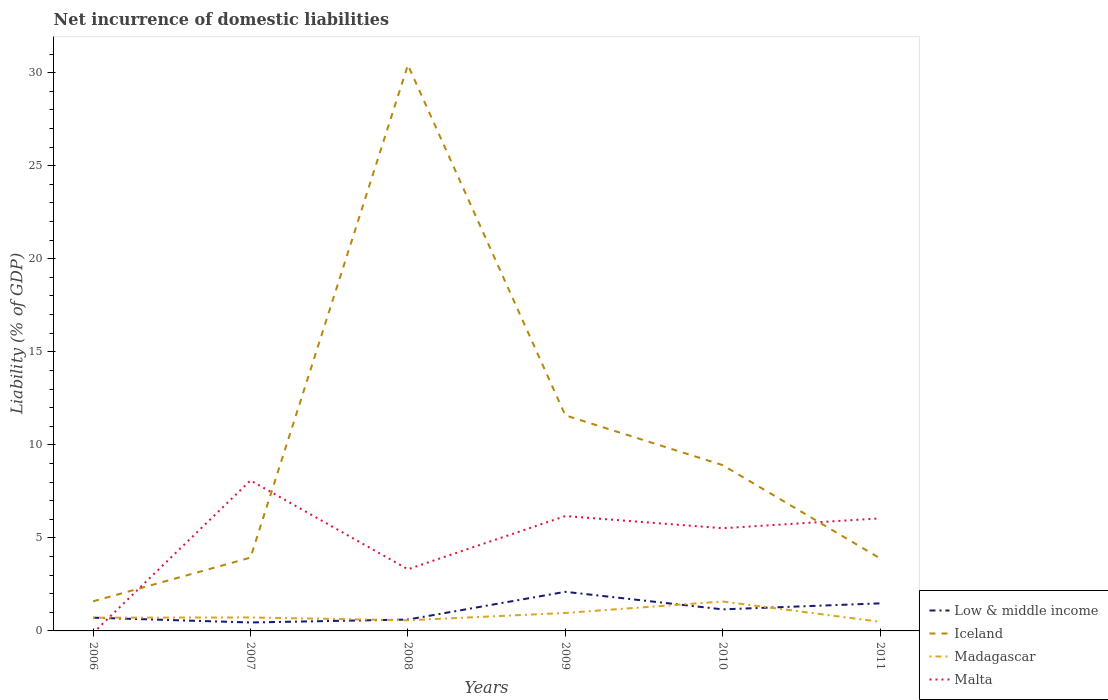Does the line corresponding to Madagascar intersect with the line corresponding to Iceland?
Ensure brevity in your answer.  No. Across all years, what is the maximum net incurrence of domestic liabilities in Malta?
Your response must be concise. 0. What is the total net incurrence of domestic liabilities in Iceland in the graph?
Your response must be concise. -10. What is the difference between the highest and the second highest net incurrence of domestic liabilities in Low & middle income?
Offer a terse response. 1.65. Is the net incurrence of domestic liabilities in Madagascar strictly greater than the net incurrence of domestic liabilities in Malta over the years?
Your response must be concise. No. How many lines are there?
Offer a very short reply. 4. How many years are there in the graph?
Make the answer very short. 6. Does the graph contain any zero values?
Your response must be concise. Yes. Where does the legend appear in the graph?
Ensure brevity in your answer.  Bottom right. How are the legend labels stacked?
Give a very brief answer. Vertical. What is the title of the graph?
Provide a short and direct response. Net incurrence of domestic liabilities. What is the label or title of the X-axis?
Your answer should be very brief. Years. What is the label or title of the Y-axis?
Your answer should be compact. Liability (% of GDP). What is the Liability (% of GDP) in Low & middle income in 2006?
Provide a short and direct response. 0.71. What is the Liability (% of GDP) of Iceland in 2006?
Your response must be concise. 1.59. What is the Liability (% of GDP) in Madagascar in 2006?
Provide a succinct answer. 0.71. What is the Liability (% of GDP) of Low & middle income in 2007?
Your answer should be very brief. 0.45. What is the Liability (% of GDP) of Iceland in 2007?
Make the answer very short. 3.94. What is the Liability (% of GDP) in Madagascar in 2007?
Make the answer very short. 0.72. What is the Liability (% of GDP) in Malta in 2007?
Offer a very short reply. 8.09. What is the Liability (% of GDP) of Low & middle income in 2008?
Give a very brief answer. 0.61. What is the Liability (% of GDP) in Iceland in 2008?
Your answer should be compact. 30.41. What is the Liability (% of GDP) in Madagascar in 2008?
Your answer should be very brief. 0.57. What is the Liability (% of GDP) in Malta in 2008?
Provide a short and direct response. 3.31. What is the Liability (% of GDP) in Low & middle income in 2009?
Your answer should be compact. 2.1. What is the Liability (% of GDP) in Iceland in 2009?
Offer a very short reply. 11.59. What is the Liability (% of GDP) of Madagascar in 2009?
Provide a succinct answer. 0.97. What is the Liability (% of GDP) in Malta in 2009?
Give a very brief answer. 6.17. What is the Liability (% of GDP) of Low & middle income in 2010?
Give a very brief answer. 1.16. What is the Liability (% of GDP) in Iceland in 2010?
Your answer should be compact. 8.91. What is the Liability (% of GDP) in Madagascar in 2010?
Your response must be concise. 1.58. What is the Liability (% of GDP) of Malta in 2010?
Offer a very short reply. 5.52. What is the Liability (% of GDP) of Low & middle income in 2011?
Provide a succinct answer. 1.48. What is the Liability (% of GDP) in Iceland in 2011?
Your response must be concise. 3.9. What is the Liability (% of GDP) of Madagascar in 2011?
Your answer should be compact. 0.49. What is the Liability (% of GDP) of Malta in 2011?
Provide a short and direct response. 6.05. Across all years, what is the maximum Liability (% of GDP) of Low & middle income?
Offer a terse response. 2.1. Across all years, what is the maximum Liability (% of GDP) in Iceland?
Ensure brevity in your answer.  30.41. Across all years, what is the maximum Liability (% of GDP) of Madagascar?
Give a very brief answer. 1.58. Across all years, what is the maximum Liability (% of GDP) of Malta?
Provide a succinct answer. 8.09. Across all years, what is the minimum Liability (% of GDP) in Low & middle income?
Provide a succinct answer. 0.45. Across all years, what is the minimum Liability (% of GDP) of Iceland?
Your response must be concise. 1.59. Across all years, what is the minimum Liability (% of GDP) of Madagascar?
Offer a terse response. 0.49. What is the total Liability (% of GDP) of Low & middle income in the graph?
Offer a very short reply. 6.52. What is the total Liability (% of GDP) in Iceland in the graph?
Give a very brief answer. 60.34. What is the total Liability (% of GDP) in Madagascar in the graph?
Offer a very short reply. 5.04. What is the total Liability (% of GDP) in Malta in the graph?
Provide a succinct answer. 29.14. What is the difference between the Liability (% of GDP) in Low & middle income in 2006 and that in 2007?
Provide a short and direct response. 0.26. What is the difference between the Liability (% of GDP) of Iceland in 2006 and that in 2007?
Keep it short and to the point. -2.35. What is the difference between the Liability (% of GDP) in Madagascar in 2006 and that in 2007?
Provide a short and direct response. -0.01. What is the difference between the Liability (% of GDP) in Low & middle income in 2006 and that in 2008?
Give a very brief answer. 0.1. What is the difference between the Liability (% of GDP) of Iceland in 2006 and that in 2008?
Make the answer very short. -28.82. What is the difference between the Liability (% of GDP) in Madagascar in 2006 and that in 2008?
Provide a succinct answer. 0.14. What is the difference between the Liability (% of GDP) in Low & middle income in 2006 and that in 2009?
Provide a succinct answer. -1.39. What is the difference between the Liability (% of GDP) of Iceland in 2006 and that in 2009?
Your answer should be compact. -10. What is the difference between the Liability (% of GDP) of Madagascar in 2006 and that in 2009?
Provide a succinct answer. -0.25. What is the difference between the Liability (% of GDP) in Low & middle income in 2006 and that in 2010?
Provide a succinct answer. -0.45. What is the difference between the Liability (% of GDP) in Iceland in 2006 and that in 2010?
Give a very brief answer. -7.32. What is the difference between the Liability (% of GDP) of Madagascar in 2006 and that in 2010?
Give a very brief answer. -0.87. What is the difference between the Liability (% of GDP) of Low & middle income in 2006 and that in 2011?
Your answer should be compact. -0.77. What is the difference between the Liability (% of GDP) of Iceland in 2006 and that in 2011?
Make the answer very short. -2.31. What is the difference between the Liability (% of GDP) in Madagascar in 2006 and that in 2011?
Give a very brief answer. 0.22. What is the difference between the Liability (% of GDP) in Low & middle income in 2007 and that in 2008?
Your response must be concise. -0.16. What is the difference between the Liability (% of GDP) of Iceland in 2007 and that in 2008?
Your answer should be very brief. -26.48. What is the difference between the Liability (% of GDP) of Madagascar in 2007 and that in 2008?
Ensure brevity in your answer.  0.15. What is the difference between the Liability (% of GDP) in Malta in 2007 and that in 2008?
Make the answer very short. 4.78. What is the difference between the Liability (% of GDP) in Low & middle income in 2007 and that in 2009?
Offer a very short reply. -1.65. What is the difference between the Liability (% of GDP) in Iceland in 2007 and that in 2009?
Your response must be concise. -7.65. What is the difference between the Liability (% of GDP) in Madagascar in 2007 and that in 2009?
Ensure brevity in your answer.  -0.24. What is the difference between the Liability (% of GDP) of Malta in 2007 and that in 2009?
Make the answer very short. 1.92. What is the difference between the Liability (% of GDP) in Low & middle income in 2007 and that in 2010?
Offer a very short reply. -0.7. What is the difference between the Liability (% of GDP) in Iceland in 2007 and that in 2010?
Your response must be concise. -4.97. What is the difference between the Liability (% of GDP) of Madagascar in 2007 and that in 2010?
Your response must be concise. -0.86. What is the difference between the Liability (% of GDP) in Malta in 2007 and that in 2010?
Offer a very short reply. 2.57. What is the difference between the Liability (% of GDP) of Low & middle income in 2007 and that in 2011?
Provide a short and direct response. -1.03. What is the difference between the Liability (% of GDP) in Iceland in 2007 and that in 2011?
Ensure brevity in your answer.  0.04. What is the difference between the Liability (% of GDP) in Madagascar in 2007 and that in 2011?
Make the answer very short. 0.23. What is the difference between the Liability (% of GDP) of Malta in 2007 and that in 2011?
Give a very brief answer. 2.04. What is the difference between the Liability (% of GDP) of Low & middle income in 2008 and that in 2009?
Keep it short and to the point. -1.49. What is the difference between the Liability (% of GDP) in Iceland in 2008 and that in 2009?
Provide a succinct answer. 18.83. What is the difference between the Liability (% of GDP) of Madagascar in 2008 and that in 2009?
Your answer should be compact. -0.39. What is the difference between the Liability (% of GDP) in Malta in 2008 and that in 2009?
Your response must be concise. -2.86. What is the difference between the Liability (% of GDP) in Low & middle income in 2008 and that in 2010?
Ensure brevity in your answer.  -0.55. What is the difference between the Liability (% of GDP) of Iceland in 2008 and that in 2010?
Give a very brief answer. 21.51. What is the difference between the Liability (% of GDP) of Madagascar in 2008 and that in 2010?
Ensure brevity in your answer.  -1.01. What is the difference between the Liability (% of GDP) in Malta in 2008 and that in 2010?
Keep it short and to the point. -2.21. What is the difference between the Liability (% of GDP) in Low & middle income in 2008 and that in 2011?
Offer a terse response. -0.87. What is the difference between the Liability (% of GDP) of Iceland in 2008 and that in 2011?
Offer a very short reply. 26.52. What is the difference between the Liability (% of GDP) in Madagascar in 2008 and that in 2011?
Your answer should be very brief. 0.08. What is the difference between the Liability (% of GDP) in Malta in 2008 and that in 2011?
Offer a terse response. -2.74. What is the difference between the Liability (% of GDP) of Low & middle income in 2009 and that in 2010?
Provide a succinct answer. 0.94. What is the difference between the Liability (% of GDP) of Iceland in 2009 and that in 2010?
Ensure brevity in your answer.  2.68. What is the difference between the Liability (% of GDP) of Madagascar in 2009 and that in 2010?
Offer a terse response. -0.62. What is the difference between the Liability (% of GDP) of Malta in 2009 and that in 2010?
Offer a very short reply. 0.65. What is the difference between the Liability (% of GDP) of Low & middle income in 2009 and that in 2011?
Give a very brief answer. 0.62. What is the difference between the Liability (% of GDP) in Iceland in 2009 and that in 2011?
Offer a terse response. 7.69. What is the difference between the Liability (% of GDP) of Madagascar in 2009 and that in 2011?
Your answer should be very brief. 0.47. What is the difference between the Liability (% of GDP) in Malta in 2009 and that in 2011?
Make the answer very short. 0.12. What is the difference between the Liability (% of GDP) of Low & middle income in 2010 and that in 2011?
Your response must be concise. -0.32. What is the difference between the Liability (% of GDP) in Iceland in 2010 and that in 2011?
Provide a short and direct response. 5.01. What is the difference between the Liability (% of GDP) of Madagascar in 2010 and that in 2011?
Keep it short and to the point. 1.09. What is the difference between the Liability (% of GDP) in Malta in 2010 and that in 2011?
Your answer should be compact. -0.53. What is the difference between the Liability (% of GDP) in Low & middle income in 2006 and the Liability (% of GDP) in Iceland in 2007?
Ensure brevity in your answer.  -3.23. What is the difference between the Liability (% of GDP) of Low & middle income in 2006 and the Liability (% of GDP) of Madagascar in 2007?
Offer a terse response. -0.01. What is the difference between the Liability (% of GDP) in Low & middle income in 2006 and the Liability (% of GDP) in Malta in 2007?
Offer a terse response. -7.38. What is the difference between the Liability (% of GDP) of Iceland in 2006 and the Liability (% of GDP) of Madagascar in 2007?
Your answer should be compact. 0.87. What is the difference between the Liability (% of GDP) of Iceland in 2006 and the Liability (% of GDP) of Malta in 2007?
Provide a short and direct response. -6.5. What is the difference between the Liability (% of GDP) in Madagascar in 2006 and the Liability (% of GDP) in Malta in 2007?
Keep it short and to the point. -7.38. What is the difference between the Liability (% of GDP) of Low & middle income in 2006 and the Liability (% of GDP) of Iceland in 2008?
Give a very brief answer. -29.7. What is the difference between the Liability (% of GDP) of Low & middle income in 2006 and the Liability (% of GDP) of Madagascar in 2008?
Offer a terse response. 0.14. What is the difference between the Liability (% of GDP) in Low & middle income in 2006 and the Liability (% of GDP) in Malta in 2008?
Ensure brevity in your answer.  -2.6. What is the difference between the Liability (% of GDP) in Iceland in 2006 and the Liability (% of GDP) in Madagascar in 2008?
Your answer should be very brief. 1.02. What is the difference between the Liability (% of GDP) in Iceland in 2006 and the Liability (% of GDP) in Malta in 2008?
Ensure brevity in your answer.  -1.72. What is the difference between the Liability (% of GDP) in Madagascar in 2006 and the Liability (% of GDP) in Malta in 2008?
Make the answer very short. -2.6. What is the difference between the Liability (% of GDP) in Low & middle income in 2006 and the Liability (% of GDP) in Iceland in 2009?
Your answer should be compact. -10.88. What is the difference between the Liability (% of GDP) in Low & middle income in 2006 and the Liability (% of GDP) in Madagascar in 2009?
Give a very brief answer. -0.25. What is the difference between the Liability (% of GDP) of Low & middle income in 2006 and the Liability (% of GDP) of Malta in 2009?
Make the answer very short. -5.46. What is the difference between the Liability (% of GDP) in Iceland in 2006 and the Liability (% of GDP) in Madagascar in 2009?
Your answer should be compact. 0.63. What is the difference between the Liability (% of GDP) of Iceland in 2006 and the Liability (% of GDP) of Malta in 2009?
Offer a very short reply. -4.58. What is the difference between the Liability (% of GDP) of Madagascar in 2006 and the Liability (% of GDP) of Malta in 2009?
Provide a succinct answer. -5.46. What is the difference between the Liability (% of GDP) of Low & middle income in 2006 and the Liability (% of GDP) of Iceland in 2010?
Offer a very short reply. -8.2. What is the difference between the Liability (% of GDP) in Low & middle income in 2006 and the Liability (% of GDP) in Madagascar in 2010?
Your response must be concise. -0.87. What is the difference between the Liability (% of GDP) in Low & middle income in 2006 and the Liability (% of GDP) in Malta in 2010?
Keep it short and to the point. -4.81. What is the difference between the Liability (% of GDP) of Iceland in 2006 and the Liability (% of GDP) of Madagascar in 2010?
Your answer should be very brief. 0.01. What is the difference between the Liability (% of GDP) of Iceland in 2006 and the Liability (% of GDP) of Malta in 2010?
Your answer should be compact. -3.93. What is the difference between the Liability (% of GDP) of Madagascar in 2006 and the Liability (% of GDP) of Malta in 2010?
Ensure brevity in your answer.  -4.81. What is the difference between the Liability (% of GDP) of Low & middle income in 2006 and the Liability (% of GDP) of Iceland in 2011?
Give a very brief answer. -3.19. What is the difference between the Liability (% of GDP) in Low & middle income in 2006 and the Liability (% of GDP) in Madagascar in 2011?
Your answer should be compact. 0.22. What is the difference between the Liability (% of GDP) in Low & middle income in 2006 and the Liability (% of GDP) in Malta in 2011?
Keep it short and to the point. -5.34. What is the difference between the Liability (% of GDP) in Iceland in 2006 and the Liability (% of GDP) in Madagascar in 2011?
Your answer should be compact. 1.1. What is the difference between the Liability (% of GDP) in Iceland in 2006 and the Liability (% of GDP) in Malta in 2011?
Your answer should be compact. -4.46. What is the difference between the Liability (% of GDP) in Madagascar in 2006 and the Liability (% of GDP) in Malta in 2011?
Ensure brevity in your answer.  -5.34. What is the difference between the Liability (% of GDP) of Low & middle income in 2007 and the Liability (% of GDP) of Iceland in 2008?
Offer a very short reply. -29.96. What is the difference between the Liability (% of GDP) in Low & middle income in 2007 and the Liability (% of GDP) in Madagascar in 2008?
Offer a terse response. -0.12. What is the difference between the Liability (% of GDP) in Low & middle income in 2007 and the Liability (% of GDP) in Malta in 2008?
Offer a very short reply. -2.86. What is the difference between the Liability (% of GDP) in Iceland in 2007 and the Liability (% of GDP) in Madagascar in 2008?
Your answer should be compact. 3.37. What is the difference between the Liability (% of GDP) of Iceland in 2007 and the Liability (% of GDP) of Malta in 2008?
Give a very brief answer. 0.63. What is the difference between the Liability (% of GDP) of Madagascar in 2007 and the Liability (% of GDP) of Malta in 2008?
Ensure brevity in your answer.  -2.59. What is the difference between the Liability (% of GDP) of Low & middle income in 2007 and the Liability (% of GDP) of Iceland in 2009?
Your response must be concise. -11.13. What is the difference between the Liability (% of GDP) in Low & middle income in 2007 and the Liability (% of GDP) in Madagascar in 2009?
Offer a very short reply. -0.51. What is the difference between the Liability (% of GDP) of Low & middle income in 2007 and the Liability (% of GDP) of Malta in 2009?
Provide a succinct answer. -5.72. What is the difference between the Liability (% of GDP) of Iceland in 2007 and the Liability (% of GDP) of Madagascar in 2009?
Your response must be concise. 2.97. What is the difference between the Liability (% of GDP) of Iceland in 2007 and the Liability (% of GDP) of Malta in 2009?
Your answer should be very brief. -2.23. What is the difference between the Liability (% of GDP) in Madagascar in 2007 and the Liability (% of GDP) in Malta in 2009?
Your answer should be compact. -5.45. What is the difference between the Liability (% of GDP) in Low & middle income in 2007 and the Liability (% of GDP) in Iceland in 2010?
Provide a succinct answer. -8.45. What is the difference between the Liability (% of GDP) in Low & middle income in 2007 and the Liability (% of GDP) in Madagascar in 2010?
Ensure brevity in your answer.  -1.13. What is the difference between the Liability (% of GDP) in Low & middle income in 2007 and the Liability (% of GDP) in Malta in 2010?
Your answer should be very brief. -5.07. What is the difference between the Liability (% of GDP) in Iceland in 2007 and the Liability (% of GDP) in Madagascar in 2010?
Provide a short and direct response. 2.36. What is the difference between the Liability (% of GDP) of Iceland in 2007 and the Liability (% of GDP) of Malta in 2010?
Make the answer very short. -1.58. What is the difference between the Liability (% of GDP) of Madagascar in 2007 and the Liability (% of GDP) of Malta in 2010?
Your answer should be very brief. -4.8. What is the difference between the Liability (% of GDP) in Low & middle income in 2007 and the Liability (% of GDP) in Iceland in 2011?
Offer a terse response. -3.44. What is the difference between the Liability (% of GDP) of Low & middle income in 2007 and the Liability (% of GDP) of Madagascar in 2011?
Your answer should be very brief. -0.04. What is the difference between the Liability (% of GDP) in Low & middle income in 2007 and the Liability (% of GDP) in Malta in 2011?
Ensure brevity in your answer.  -5.6. What is the difference between the Liability (% of GDP) in Iceland in 2007 and the Liability (% of GDP) in Madagascar in 2011?
Your answer should be very brief. 3.45. What is the difference between the Liability (% of GDP) of Iceland in 2007 and the Liability (% of GDP) of Malta in 2011?
Keep it short and to the point. -2.11. What is the difference between the Liability (% of GDP) in Madagascar in 2007 and the Liability (% of GDP) in Malta in 2011?
Give a very brief answer. -5.33. What is the difference between the Liability (% of GDP) of Low & middle income in 2008 and the Liability (% of GDP) of Iceland in 2009?
Provide a succinct answer. -10.97. What is the difference between the Liability (% of GDP) of Low & middle income in 2008 and the Liability (% of GDP) of Madagascar in 2009?
Offer a very short reply. -0.35. What is the difference between the Liability (% of GDP) in Low & middle income in 2008 and the Liability (% of GDP) in Malta in 2009?
Offer a terse response. -5.56. What is the difference between the Liability (% of GDP) of Iceland in 2008 and the Liability (% of GDP) of Madagascar in 2009?
Offer a terse response. 29.45. What is the difference between the Liability (% of GDP) in Iceland in 2008 and the Liability (% of GDP) in Malta in 2009?
Your response must be concise. 24.24. What is the difference between the Liability (% of GDP) in Madagascar in 2008 and the Liability (% of GDP) in Malta in 2009?
Your response must be concise. -5.6. What is the difference between the Liability (% of GDP) of Low & middle income in 2008 and the Liability (% of GDP) of Iceland in 2010?
Your answer should be very brief. -8.3. What is the difference between the Liability (% of GDP) in Low & middle income in 2008 and the Liability (% of GDP) in Madagascar in 2010?
Your answer should be very brief. -0.97. What is the difference between the Liability (% of GDP) of Low & middle income in 2008 and the Liability (% of GDP) of Malta in 2010?
Keep it short and to the point. -4.91. What is the difference between the Liability (% of GDP) in Iceland in 2008 and the Liability (% of GDP) in Madagascar in 2010?
Keep it short and to the point. 28.83. What is the difference between the Liability (% of GDP) of Iceland in 2008 and the Liability (% of GDP) of Malta in 2010?
Ensure brevity in your answer.  24.9. What is the difference between the Liability (% of GDP) in Madagascar in 2008 and the Liability (% of GDP) in Malta in 2010?
Provide a short and direct response. -4.95. What is the difference between the Liability (% of GDP) in Low & middle income in 2008 and the Liability (% of GDP) in Iceland in 2011?
Your answer should be compact. -3.29. What is the difference between the Liability (% of GDP) of Low & middle income in 2008 and the Liability (% of GDP) of Madagascar in 2011?
Keep it short and to the point. 0.12. What is the difference between the Liability (% of GDP) in Low & middle income in 2008 and the Liability (% of GDP) in Malta in 2011?
Keep it short and to the point. -5.44. What is the difference between the Liability (% of GDP) of Iceland in 2008 and the Liability (% of GDP) of Madagascar in 2011?
Your response must be concise. 29.92. What is the difference between the Liability (% of GDP) of Iceland in 2008 and the Liability (% of GDP) of Malta in 2011?
Make the answer very short. 24.37. What is the difference between the Liability (% of GDP) of Madagascar in 2008 and the Liability (% of GDP) of Malta in 2011?
Offer a terse response. -5.48. What is the difference between the Liability (% of GDP) of Low & middle income in 2009 and the Liability (% of GDP) of Iceland in 2010?
Offer a terse response. -6.81. What is the difference between the Liability (% of GDP) of Low & middle income in 2009 and the Liability (% of GDP) of Madagascar in 2010?
Give a very brief answer. 0.52. What is the difference between the Liability (% of GDP) of Low & middle income in 2009 and the Liability (% of GDP) of Malta in 2010?
Give a very brief answer. -3.42. What is the difference between the Liability (% of GDP) in Iceland in 2009 and the Liability (% of GDP) in Madagascar in 2010?
Offer a terse response. 10. What is the difference between the Liability (% of GDP) in Iceland in 2009 and the Liability (% of GDP) in Malta in 2010?
Offer a very short reply. 6.07. What is the difference between the Liability (% of GDP) in Madagascar in 2009 and the Liability (% of GDP) in Malta in 2010?
Your response must be concise. -4.55. What is the difference between the Liability (% of GDP) of Low & middle income in 2009 and the Liability (% of GDP) of Iceland in 2011?
Your answer should be very brief. -1.8. What is the difference between the Liability (% of GDP) of Low & middle income in 2009 and the Liability (% of GDP) of Madagascar in 2011?
Give a very brief answer. 1.61. What is the difference between the Liability (% of GDP) in Low & middle income in 2009 and the Liability (% of GDP) in Malta in 2011?
Offer a terse response. -3.95. What is the difference between the Liability (% of GDP) of Iceland in 2009 and the Liability (% of GDP) of Madagascar in 2011?
Offer a very short reply. 11.1. What is the difference between the Liability (% of GDP) in Iceland in 2009 and the Liability (% of GDP) in Malta in 2011?
Your response must be concise. 5.54. What is the difference between the Liability (% of GDP) of Madagascar in 2009 and the Liability (% of GDP) of Malta in 2011?
Ensure brevity in your answer.  -5.08. What is the difference between the Liability (% of GDP) of Low & middle income in 2010 and the Liability (% of GDP) of Iceland in 2011?
Your response must be concise. -2.74. What is the difference between the Liability (% of GDP) in Low & middle income in 2010 and the Liability (% of GDP) in Madagascar in 2011?
Ensure brevity in your answer.  0.67. What is the difference between the Liability (% of GDP) in Low & middle income in 2010 and the Liability (% of GDP) in Malta in 2011?
Your answer should be very brief. -4.89. What is the difference between the Liability (% of GDP) of Iceland in 2010 and the Liability (% of GDP) of Madagascar in 2011?
Your answer should be compact. 8.42. What is the difference between the Liability (% of GDP) in Iceland in 2010 and the Liability (% of GDP) in Malta in 2011?
Your response must be concise. 2.86. What is the difference between the Liability (% of GDP) of Madagascar in 2010 and the Liability (% of GDP) of Malta in 2011?
Your answer should be compact. -4.47. What is the average Liability (% of GDP) in Low & middle income per year?
Ensure brevity in your answer.  1.09. What is the average Liability (% of GDP) in Iceland per year?
Give a very brief answer. 10.06. What is the average Liability (% of GDP) of Madagascar per year?
Offer a terse response. 0.84. What is the average Liability (% of GDP) of Malta per year?
Provide a succinct answer. 4.86. In the year 2006, what is the difference between the Liability (% of GDP) in Low & middle income and Liability (% of GDP) in Iceland?
Offer a very short reply. -0.88. In the year 2006, what is the difference between the Liability (% of GDP) in Low & middle income and Liability (% of GDP) in Madagascar?
Provide a short and direct response. -0. In the year 2006, what is the difference between the Liability (% of GDP) of Iceland and Liability (% of GDP) of Madagascar?
Give a very brief answer. 0.88. In the year 2007, what is the difference between the Liability (% of GDP) of Low & middle income and Liability (% of GDP) of Iceland?
Ensure brevity in your answer.  -3.48. In the year 2007, what is the difference between the Liability (% of GDP) of Low & middle income and Liability (% of GDP) of Madagascar?
Your response must be concise. -0.27. In the year 2007, what is the difference between the Liability (% of GDP) of Low & middle income and Liability (% of GDP) of Malta?
Your answer should be very brief. -7.63. In the year 2007, what is the difference between the Liability (% of GDP) in Iceland and Liability (% of GDP) in Madagascar?
Provide a succinct answer. 3.21. In the year 2007, what is the difference between the Liability (% of GDP) of Iceland and Liability (% of GDP) of Malta?
Your answer should be compact. -4.15. In the year 2007, what is the difference between the Liability (% of GDP) of Madagascar and Liability (% of GDP) of Malta?
Ensure brevity in your answer.  -7.36. In the year 2008, what is the difference between the Liability (% of GDP) of Low & middle income and Liability (% of GDP) of Iceland?
Keep it short and to the point. -29.8. In the year 2008, what is the difference between the Liability (% of GDP) of Low & middle income and Liability (% of GDP) of Madagascar?
Your answer should be very brief. 0.04. In the year 2008, what is the difference between the Liability (% of GDP) in Low & middle income and Liability (% of GDP) in Malta?
Your answer should be compact. -2.7. In the year 2008, what is the difference between the Liability (% of GDP) in Iceland and Liability (% of GDP) in Madagascar?
Offer a very short reply. 29.84. In the year 2008, what is the difference between the Liability (% of GDP) in Iceland and Liability (% of GDP) in Malta?
Your answer should be compact. 27.1. In the year 2008, what is the difference between the Liability (% of GDP) in Madagascar and Liability (% of GDP) in Malta?
Your response must be concise. -2.74. In the year 2009, what is the difference between the Liability (% of GDP) in Low & middle income and Liability (% of GDP) in Iceland?
Keep it short and to the point. -9.48. In the year 2009, what is the difference between the Liability (% of GDP) in Low & middle income and Liability (% of GDP) in Madagascar?
Offer a very short reply. 1.14. In the year 2009, what is the difference between the Liability (% of GDP) of Low & middle income and Liability (% of GDP) of Malta?
Give a very brief answer. -4.07. In the year 2009, what is the difference between the Liability (% of GDP) of Iceland and Liability (% of GDP) of Madagascar?
Provide a succinct answer. 10.62. In the year 2009, what is the difference between the Liability (% of GDP) of Iceland and Liability (% of GDP) of Malta?
Your answer should be compact. 5.41. In the year 2009, what is the difference between the Liability (% of GDP) of Madagascar and Liability (% of GDP) of Malta?
Ensure brevity in your answer.  -5.21. In the year 2010, what is the difference between the Liability (% of GDP) of Low & middle income and Liability (% of GDP) of Iceland?
Give a very brief answer. -7.75. In the year 2010, what is the difference between the Liability (% of GDP) of Low & middle income and Liability (% of GDP) of Madagascar?
Offer a terse response. -0.42. In the year 2010, what is the difference between the Liability (% of GDP) in Low & middle income and Liability (% of GDP) in Malta?
Ensure brevity in your answer.  -4.36. In the year 2010, what is the difference between the Liability (% of GDP) in Iceland and Liability (% of GDP) in Madagascar?
Your answer should be very brief. 7.33. In the year 2010, what is the difference between the Liability (% of GDP) in Iceland and Liability (% of GDP) in Malta?
Provide a succinct answer. 3.39. In the year 2010, what is the difference between the Liability (% of GDP) of Madagascar and Liability (% of GDP) of Malta?
Keep it short and to the point. -3.94. In the year 2011, what is the difference between the Liability (% of GDP) of Low & middle income and Liability (% of GDP) of Iceland?
Keep it short and to the point. -2.42. In the year 2011, what is the difference between the Liability (% of GDP) of Low & middle income and Liability (% of GDP) of Madagascar?
Offer a very short reply. 0.99. In the year 2011, what is the difference between the Liability (% of GDP) of Low & middle income and Liability (% of GDP) of Malta?
Give a very brief answer. -4.57. In the year 2011, what is the difference between the Liability (% of GDP) of Iceland and Liability (% of GDP) of Madagascar?
Offer a terse response. 3.41. In the year 2011, what is the difference between the Liability (% of GDP) of Iceland and Liability (% of GDP) of Malta?
Offer a very short reply. -2.15. In the year 2011, what is the difference between the Liability (% of GDP) in Madagascar and Liability (% of GDP) in Malta?
Your answer should be very brief. -5.56. What is the ratio of the Liability (% of GDP) in Low & middle income in 2006 to that in 2007?
Provide a short and direct response. 1.57. What is the ratio of the Liability (% of GDP) in Iceland in 2006 to that in 2007?
Your answer should be compact. 0.4. What is the ratio of the Liability (% of GDP) in Madagascar in 2006 to that in 2007?
Offer a terse response. 0.98. What is the ratio of the Liability (% of GDP) in Low & middle income in 2006 to that in 2008?
Provide a succinct answer. 1.16. What is the ratio of the Liability (% of GDP) of Iceland in 2006 to that in 2008?
Your response must be concise. 0.05. What is the ratio of the Liability (% of GDP) of Madagascar in 2006 to that in 2008?
Offer a very short reply. 1.24. What is the ratio of the Liability (% of GDP) of Low & middle income in 2006 to that in 2009?
Offer a terse response. 0.34. What is the ratio of the Liability (% of GDP) of Iceland in 2006 to that in 2009?
Provide a succinct answer. 0.14. What is the ratio of the Liability (% of GDP) in Madagascar in 2006 to that in 2009?
Offer a very short reply. 0.74. What is the ratio of the Liability (% of GDP) in Low & middle income in 2006 to that in 2010?
Keep it short and to the point. 0.61. What is the ratio of the Liability (% of GDP) in Iceland in 2006 to that in 2010?
Keep it short and to the point. 0.18. What is the ratio of the Liability (% of GDP) in Madagascar in 2006 to that in 2010?
Your answer should be very brief. 0.45. What is the ratio of the Liability (% of GDP) of Low & middle income in 2006 to that in 2011?
Offer a very short reply. 0.48. What is the ratio of the Liability (% of GDP) in Iceland in 2006 to that in 2011?
Offer a terse response. 0.41. What is the ratio of the Liability (% of GDP) in Madagascar in 2006 to that in 2011?
Your answer should be very brief. 1.45. What is the ratio of the Liability (% of GDP) of Low & middle income in 2007 to that in 2008?
Your response must be concise. 0.74. What is the ratio of the Liability (% of GDP) of Iceland in 2007 to that in 2008?
Make the answer very short. 0.13. What is the ratio of the Liability (% of GDP) in Madagascar in 2007 to that in 2008?
Your answer should be compact. 1.27. What is the ratio of the Liability (% of GDP) of Malta in 2007 to that in 2008?
Keep it short and to the point. 2.44. What is the ratio of the Liability (% of GDP) of Low & middle income in 2007 to that in 2009?
Provide a succinct answer. 0.22. What is the ratio of the Liability (% of GDP) in Iceland in 2007 to that in 2009?
Your answer should be very brief. 0.34. What is the ratio of the Liability (% of GDP) of Madagascar in 2007 to that in 2009?
Your answer should be compact. 0.75. What is the ratio of the Liability (% of GDP) of Malta in 2007 to that in 2009?
Your answer should be very brief. 1.31. What is the ratio of the Liability (% of GDP) of Low & middle income in 2007 to that in 2010?
Offer a terse response. 0.39. What is the ratio of the Liability (% of GDP) in Iceland in 2007 to that in 2010?
Offer a very short reply. 0.44. What is the ratio of the Liability (% of GDP) of Madagascar in 2007 to that in 2010?
Ensure brevity in your answer.  0.46. What is the ratio of the Liability (% of GDP) in Malta in 2007 to that in 2010?
Your answer should be compact. 1.47. What is the ratio of the Liability (% of GDP) of Low & middle income in 2007 to that in 2011?
Provide a short and direct response. 0.31. What is the ratio of the Liability (% of GDP) in Iceland in 2007 to that in 2011?
Offer a terse response. 1.01. What is the ratio of the Liability (% of GDP) of Madagascar in 2007 to that in 2011?
Your answer should be very brief. 1.47. What is the ratio of the Liability (% of GDP) in Malta in 2007 to that in 2011?
Your response must be concise. 1.34. What is the ratio of the Liability (% of GDP) in Low & middle income in 2008 to that in 2009?
Give a very brief answer. 0.29. What is the ratio of the Liability (% of GDP) of Iceland in 2008 to that in 2009?
Your answer should be compact. 2.63. What is the ratio of the Liability (% of GDP) in Madagascar in 2008 to that in 2009?
Provide a short and direct response. 0.59. What is the ratio of the Liability (% of GDP) of Malta in 2008 to that in 2009?
Ensure brevity in your answer.  0.54. What is the ratio of the Liability (% of GDP) in Low & middle income in 2008 to that in 2010?
Give a very brief answer. 0.53. What is the ratio of the Liability (% of GDP) in Iceland in 2008 to that in 2010?
Offer a terse response. 3.41. What is the ratio of the Liability (% of GDP) of Madagascar in 2008 to that in 2010?
Offer a terse response. 0.36. What is the ratio of the Liability (% of GDP) in Malta in 2008 to that in 2010?
Offer a very short reply. 0.6. What is the ratio of the Liability (% of GDP) in Low & middle income in 2008 to that in 2011?
Keep it short and to the point. 0.41. What is the ratio of the Liability (% of GDP) in Iceland in 2008 to that in 2011?
Offer a very short reply. 7.8. What is the ratio of the Liability (% of GDP) of Madagascar in 2008 to that in 2011?
Provide a succinct answer. 1.16. What is the ratio of the Liability (% of GDP) of Malta in 2008 to that in 2011?
Offer a very short reply. 0.55. What is the ratio of the Liability (% of GDP) in Low & middle income in 2009 to that in 2010?
Offer a very short reply. 1.81. What is the ratio of the Liability (% of GDP) in Iceland in 2009 to that in 2010?
Your answer should be compact. 1.3. What is the ratio of the Liability (% of GDP) of Madagascar in 2009 to that in 2010?
Your answer should be very brief. 0.61. What is the ratio of the Liability (% of GDP) in Malta in 2009 to that in 2010?
Provide a short and direct response. 1.12. What is the ratio of the Liability (% of GDP) in Low & middle income in 2009 to that in 2011?
Ensure brevity in your answer.  1.42. What is the ratio of the Liability (% of GDP) in Iceland in 2009 to that in 2011?
Your response must be concise. 2.97. What is the ratio of the Liability (% of GDP) in Madagascar in 2009 to that in 2011?
Provide a succinct answer. 1.97. What is the ratio of the Liability (% of GDP) of Malta in 2009 to that in 2011?
Provide a succinct answer. 1.02. What is the ratio of the Liability (% of GDP) in Low & middle income in 2010 to that in 2011?
Your answer should be compact. 0.78. What is the ratio of the Liability (% of GDP) in Iceland in 2010 to that in 2011?
Provide a short and direct response. 2.29. What is the ratio of the Liability (% of GDP) in Madagascar in 2010 to that in 2011?
Ensure brevity in your answer.  3.22. What is the ratio of the Liability (% of GDP) of Malta in 2010 to that in 2011?
Your answer should be very brief. 0.91. What is the difference between the highest and the second highest Liability (% of GDP) in Low & middle income?
Your answer should be compact. 0.62. What is the difference between the highest and the second highest Liability (% of GDP) of Iceland?
Make the answer very short. 18.83. What is the difference between the highest and the second highest Liability (% of GDP) in Madagascar?
Provide a succinct answer. 0.62. What is the difference between the highest and the second highest Liability (% of GDP) of Malta?
Offer a terse response. 1.92. What is the difference between the highest and the lowest Liability (% of GDP) in Low & middle income?
Make the answer very short. 1.65. What is the difference between the highest and the lowest Liability (% of GDP) of Iceland?
Provide a succinct answer. 28.82. What is the difference between the highest and the lowest Liability (% of GDP) in Madagascar?
Your answer should be very brief. 1.09. What is the difference between the highest and the lowest Liability (% of GDP) of Malta?
Give a very brief answer. 8.09. 